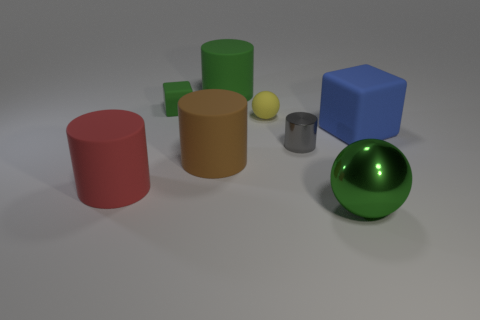What is the shape of the red thing that is the same material as the large brown cylinder?
Offer a terse response. Cylinder. How many yellow objects are either small cubes or metal cylinders?
Make the answer very short. 0. There is a blue rubber block; are there any big green shiny objects in front of it?
Your answer should be compact. Yes. There is a green thing that is in front of the large brown cylinder; is it the same shape as the metal object that is behind the red thing?
Your response must be concise. No. There is a large object that is the same shape as the tiny green object; what material is it?
Provide a succinct answer. Rubber. How many balls are large red metal things or large metallic things?
Provide a succinct answer. 1. What number of small cubes are the same material as the small gray thing?
Provide a succinct answer. 0. Do the large object that is in front of the large red rubber cylinder and the cube to the right of the tiny matte cube have the same material?
Give a very brief answer. No. How many yellow matte balls are to the right of the green thing to the left of the green rubber cylinder behind the large brown cylinder?
Your answer should be very brief. 1. There is a cube that is to the left of the large blue cube; does it have the same color as the ball in front of the large brown thing?
Provide a short and direct response. Yes. 